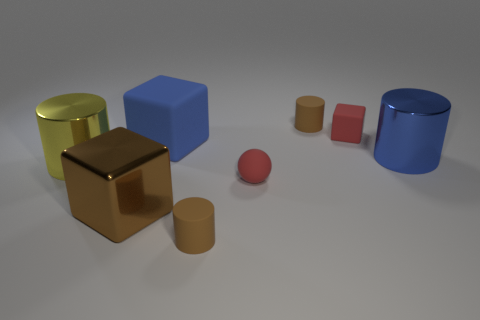What is the color of the cylinder that is the same size as the blue metal object?
Your response must be concise. Yellow. What number of metal things are either yellow cylinders or big blocks?
Offer a terse response. 2. There is a rubber cube that is behind the blue block; what number of large blue things are behind it?
Keep it short and to the point. 0. The cube that is the same color as the small ball is what size?
Provide a short and direct response. Small. What number of objects are balls or cylinders behind the red ball?
Your answer should be compact. 4. Are there any objects that have the same material as the tiny cube?
Offer a terse response. Yes. What number of objects are both in front of the yellow cylinder and to the right of the blue matte block?
Give a very brief answer. 2. What is the material of the ball in front of the yellow cylinder?
Give a very brief answer. Rubber. There is a blue thing that is made of the same material as the red ball; what is its size?
Offer a terse response. Large. Are there any big brown metallic objects behind the small rubber sphere?
Provide a short and direct response. No. 